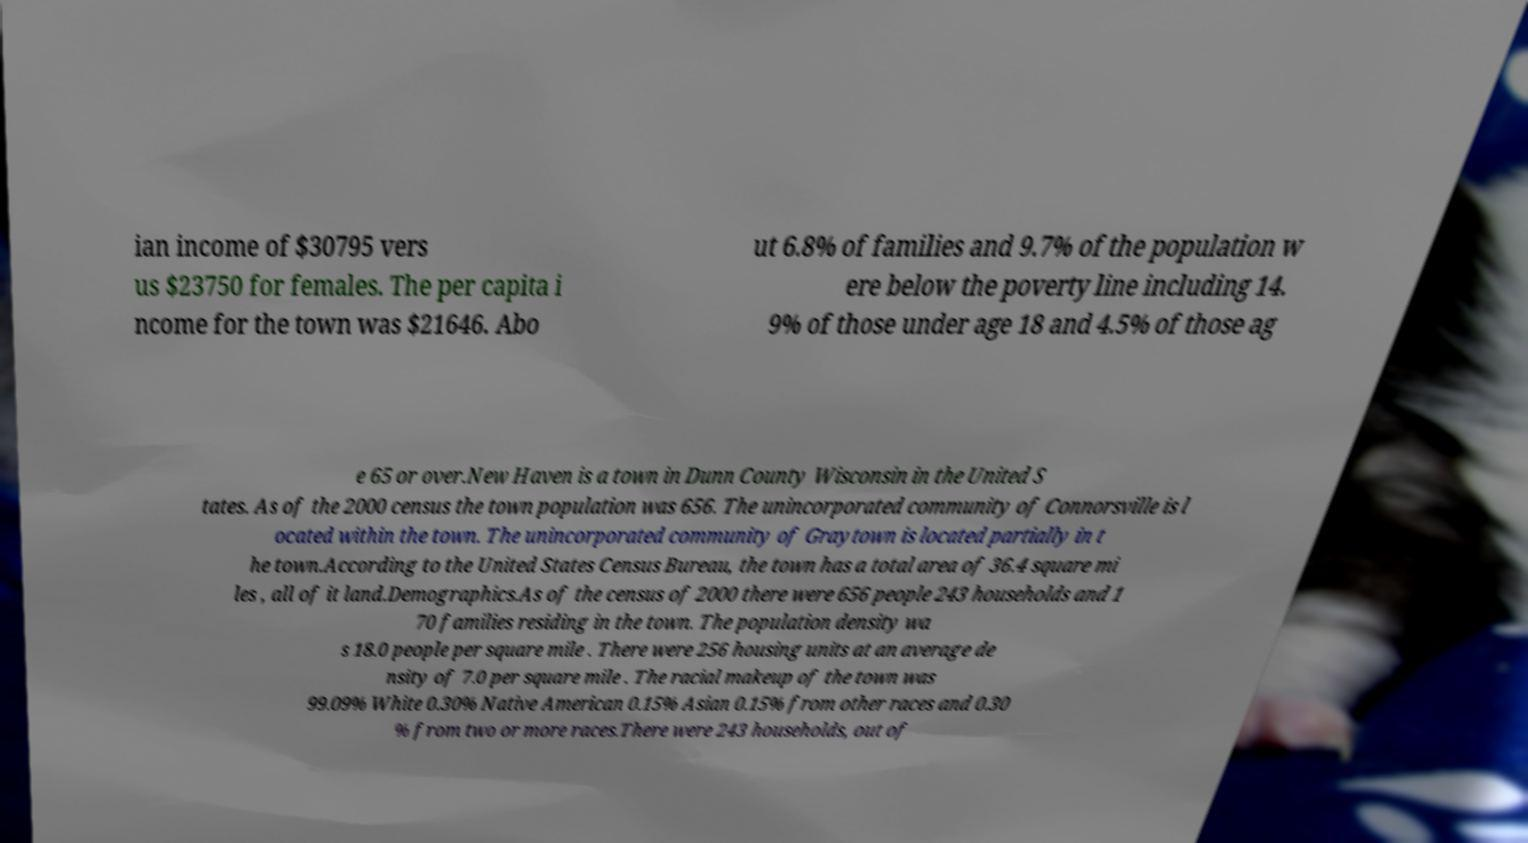Can you read and provide the text displayed in the image?This photo seems to have some interesting text. Can you extract and type it out for me? ian income of $30795 vers us $23750 for females. The per capita i ncome for the town was $21646. Abo ut 6.8% of families and 9.7% of the population w ere below the poverty line including 14. 9% of those under age 18 and 4.5% of those ag e 65 or over.New Haven is a town in Dunn County Wisconsin in the United S tates. As of the 2000 census the town population was 656. The unincorporated community of Connorsville is l ocated within the town. The unincorporated community of Graytown is located partially in t he town.According to the United States Census Bureau, the town has a total area of 36.4 square mi les , all of it land.Demographics.As of the census of 2000 there were 656 people 243 households and 1 70 families residing in the town. The population density wa s 18.0 people per square mile . There were 256 housing units at an average de nsity of 7.0 per square mile . The racial makeup of the town was 99.09% White 0.30% Native American 0.15% Asian 0.15% from other races and 0.30 % from two or more races.There were 243 households, out of 